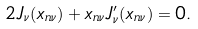<formula> <loc_0><loc_0><loc_500><loc_500>2 J _ { \nu } ( x _ { n \nu } ) + x _ { n \nu } J ^ { \prime } _ { \nu } ( x _ { n \nu } ) = 0 .</formula> 